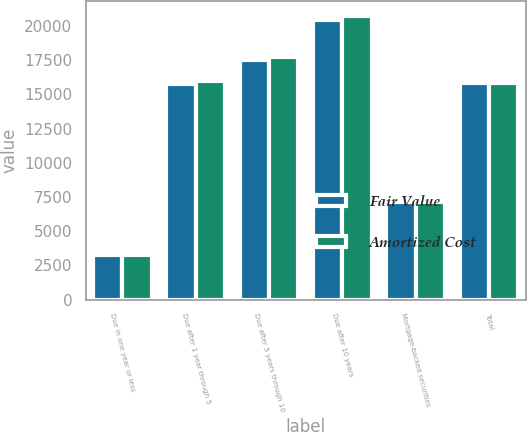<chart> <loc_0><loc_0><loc_500><loc_500><stacked_bar_chart><ecel><fcel>Due in one year or less<fcel>Due after 1 year through 5<fcel>Due after 5 years through 10<fcel>Due after 10 years<fcel>Mortgage-backed securities<fcel>Total<nl><fcel>Fair Value<fcel>3288<fcel>15745<fcel>17558<fcel>20453<fcel>7108<fcel>15853.5<nl><fcel>Amortized Cost<fcel>3292<fcel>15962<fcel>17777<fcel>20773<fcel>7116<fcel>15853.5<nl></chart> 